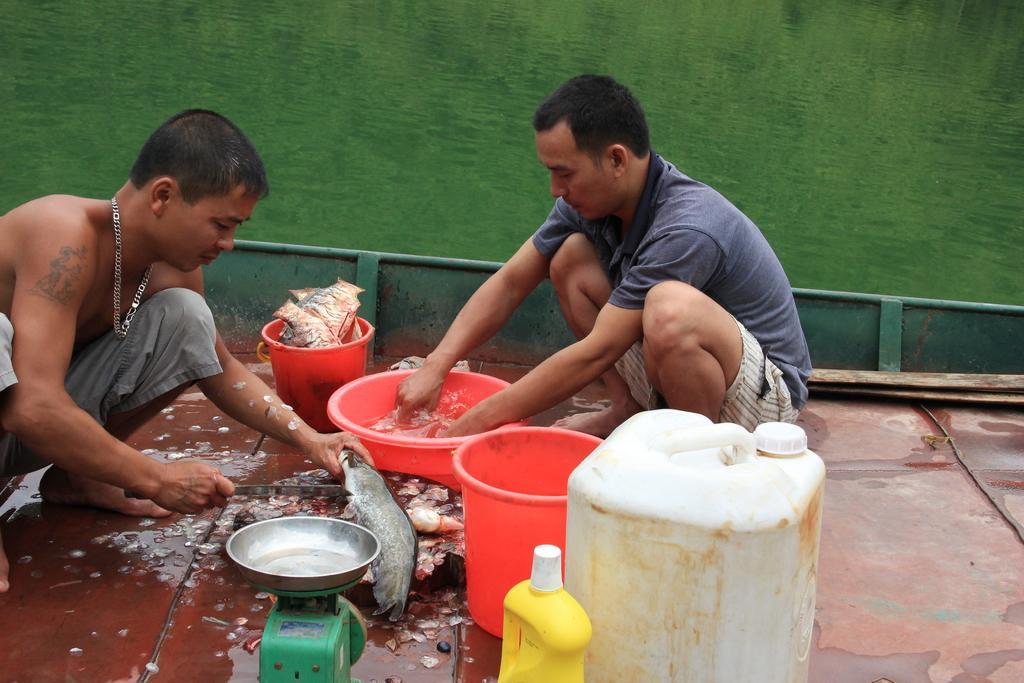Can you describe this image briefly? In this image we can see two persons sitting on the floor and washing dishes. Other than this we can also see weighing machine, fish, buckets and a bin. 